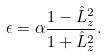Convert formula to latex. <formula><loc_0><loc_0><loc_500><loc_500>\epsilon = \alpha \frac { 1 - \hat { L } _ { z } ^ { 2 } } { 1 + \hat { L } _ { z } ^ { 2 } } .</formula> 